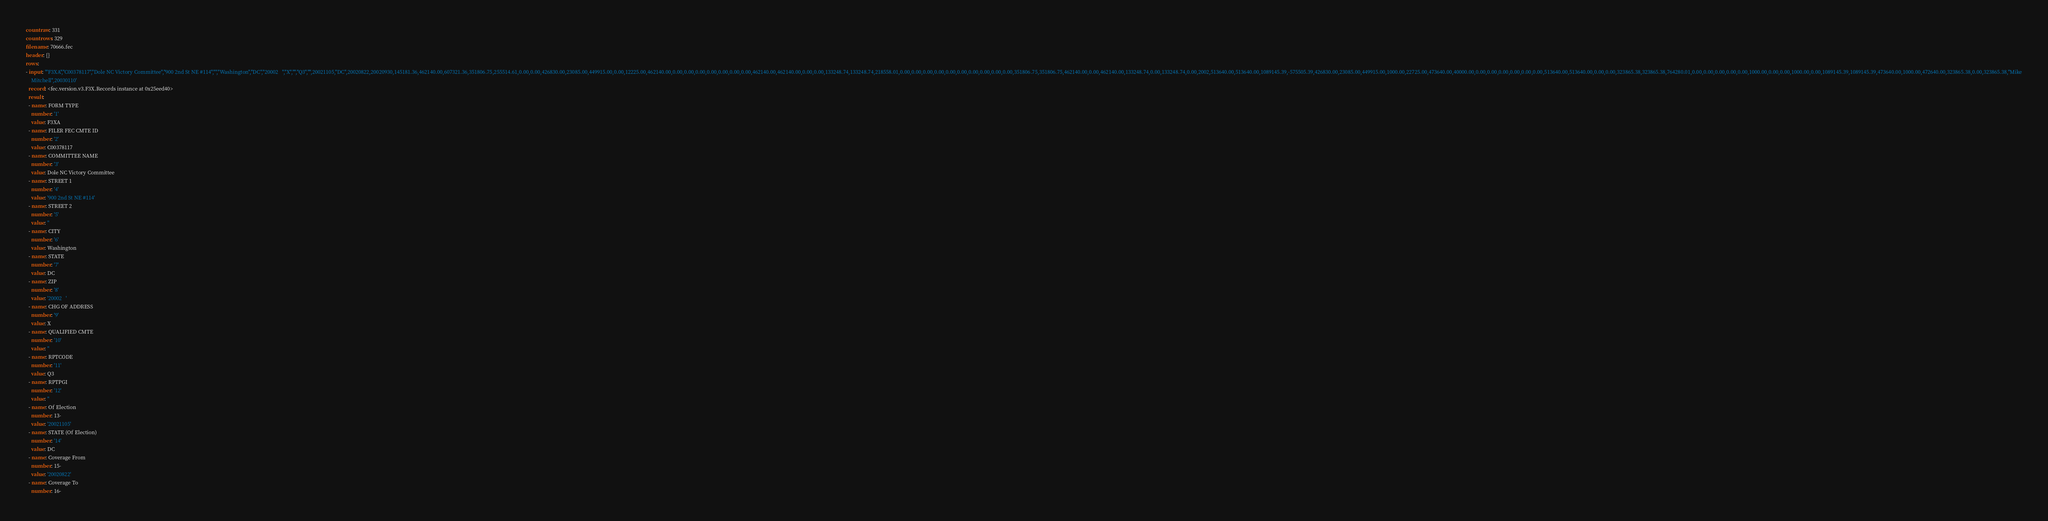Convert code to text. <code><loc_0><loc_0><loc_500><loc_500><_YAML_>countraw: 331
countrows: 329
filename: 70666.fec
header: {}
rows:
- input: '"F3XA","C00378117","Dole NC Victory Committee","900 2nd St NE #114","","Washington","DC","20002   ","X","","Q3","",20021105,"DC",20020822,20020930,145181.36,462140.00,607321.36,351806.75,255514.61,0.00,0.00,426830.00,23085.00,449915.00,0.00,12225.00,462140.00,0.00,0.00,0.00,0.00,0.00,0.00,0.00,462140.00,462140.00,0.00,0.00,133248.74,133248.74,218558.01,0.00,0.00,0.00,0.00,0.00,0.00,0.00,0.00,0.00,0.00,351806.75,351806.75,462140.00,0.00,462140.00,133248.74,0.00,133248.74,0.00,2002,513640.00,513640.00,1089145.39,-575505.39,426830.00,23085.00,449915.00,1000.00,22725.00,473640.00,40000.00,0.00,0.00,0.00,0.00,0.00,0.00,513640.00,513640.00,0.00,0.00,323865.38,323865.38,764280.01,0.00,0.00,0.00,0.00,0.00,1000.00,0.00,0.00,1000.00,0.00,1089145.39,1089145.39,473640.00,1000.00,472640.00,323865.38,0.00,323865.38,"Mike
    Mitchell",20030110'
  record: <fec.version.v3.F3X.Records instance at 0x25eed40>
  result:
  - name: FORM TYPE
    number: '1'
    value: F3XA
  - name: FILER FEC CMTE ID
    number: '2'
    value: C00378117
  - name: COMMITTEE NAME
    number: '3'
    value: Dole NC Victory Committee
  - name: STREET 1
    number: '4'
    value: '900 2nd St NE #114'
  - name: STREET 2
    number: '5'
    value: ''
  - name: CITY
    number: '6'
    value: Washington
  - name: STATE
    number: '7'
    value: DC
  - name: ZIP
    number: '8'
    value: '20002   '
  - name: CHG OF ADDRESS
    number: '9'
    value: X
  - name: QUALIFIED CMTE
    number: '10'
    value: ''
  - name: RPTCODE
    number: '11'
    value: Q3
  - name: RPTPGI
    number: '12'
    value: ''
  - name: Of Election
    number: 13-
    value: '20021105'
  - name: STATE (Of Election)
    number: '14'
    value: DC
  - name: Coverage From
    number: 15-
    value: '20020822'
  - name: Coverage To
    number: 16-</code> 